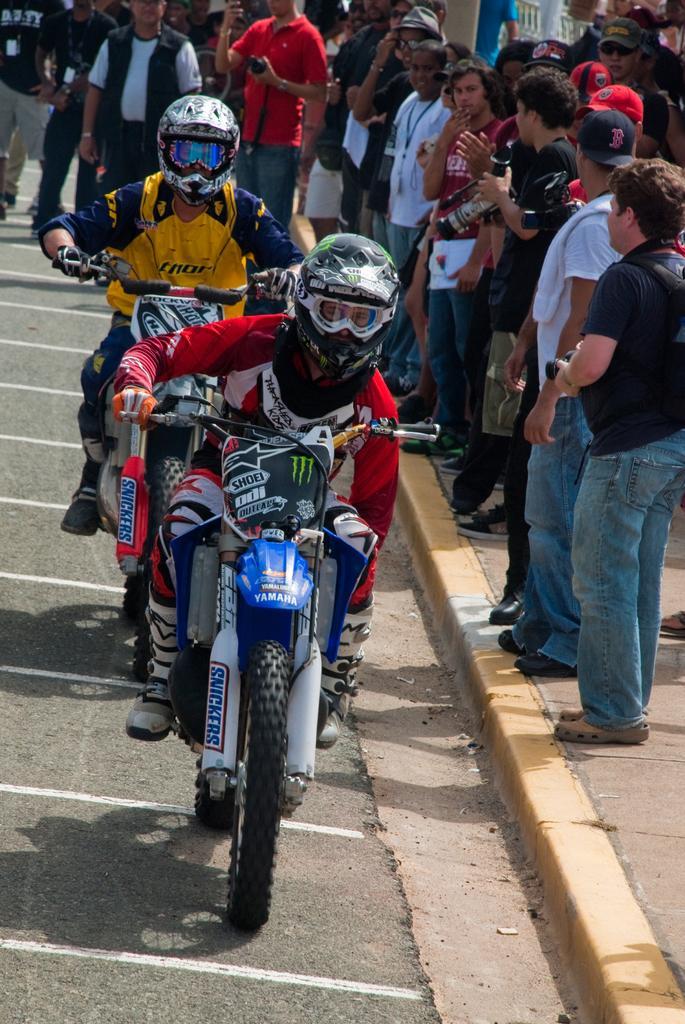Please provide a concise description of this image. Two men are riding bike on the road with some people at the background. 